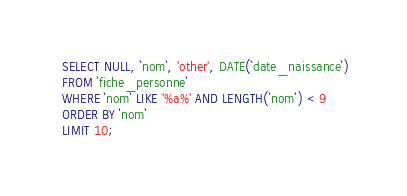Convert code to text. <code><loc_0><loc_0><loc_500><loc_500><_SQL_> SELECT NULL, `nom`, 'other', DATE(`date_naissance`)
 FROM `fiche_personne`
 WHERE `nom` LIKE '%a%' AND LENGTH(`nom`) < 9
 ORDER BY `nom`
 LIMIT 10;
</code> 